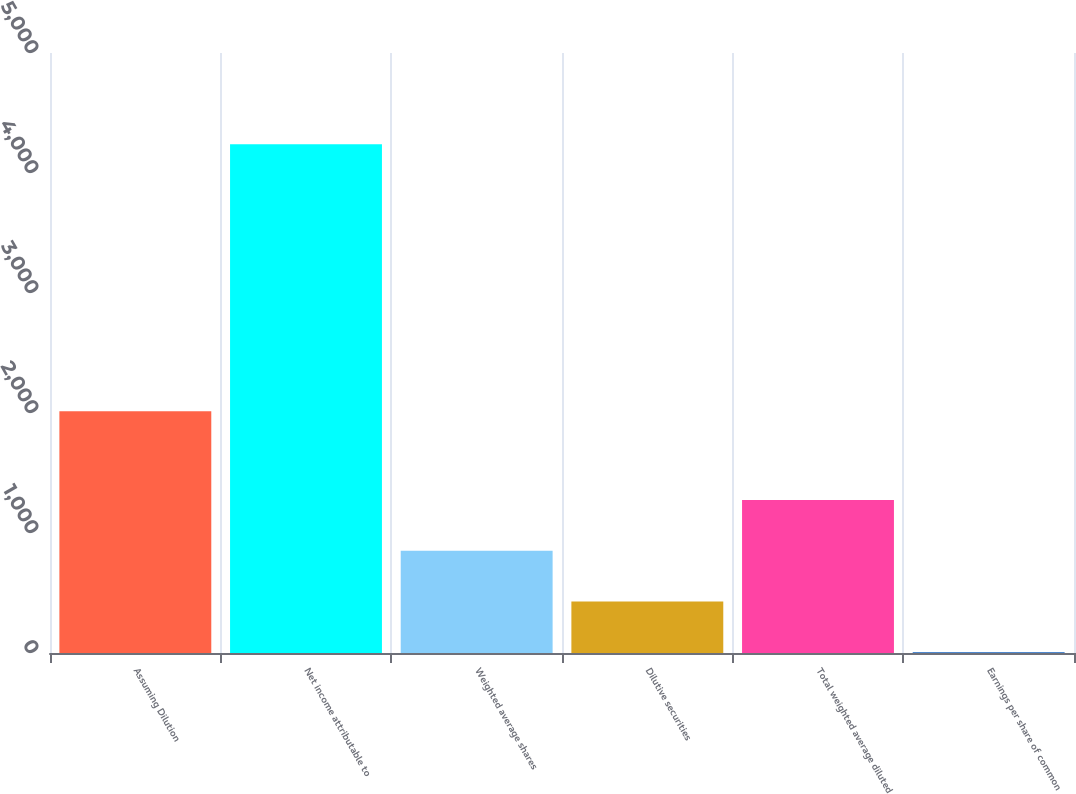Convert chart to OTSL. <chart><loc_0><loc_0><loc_500><loc_500><bar_chart><fcel>Assuming Dilution<fcel>Net income attributable to<fcel>Weighted average shares<fcel>Dilutive securities<fcel>Total weighted average diluted<fcel>Earnings per share of common<nl><fcel>2014<fcel>4239<fcel>852.07<fcel>428.7<fcel>1275.44<fcel>5.33<nl></chart> 